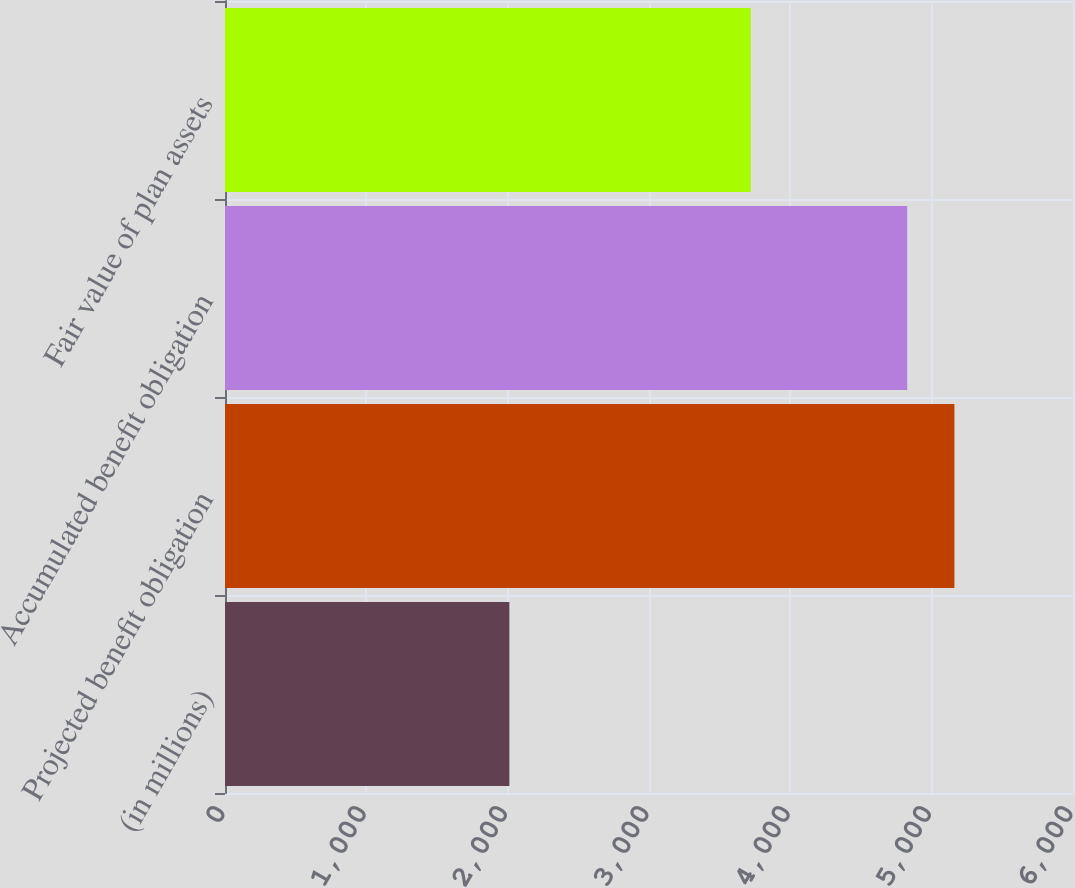Convert chart. <chart><loc_0><loc_0><loc_500><loc_500><bar_chart><fcel>(in millions)<fcel>Projected benefit obligation<fcel>Accumulated benefit obligation<fcel>Fair value of plan assets<nl><fcel>2012<fcel>5161<fcel>4827<fcel>3720<nl></chart> 